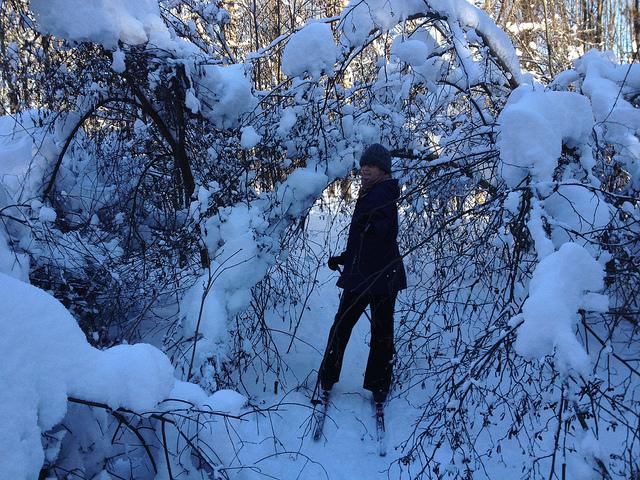Has much snow fallen?
Short answer required. Lot. Does this person have skis on?
Be succinct. Yes. Is this person a male or female?
Answer briefly. Female. 